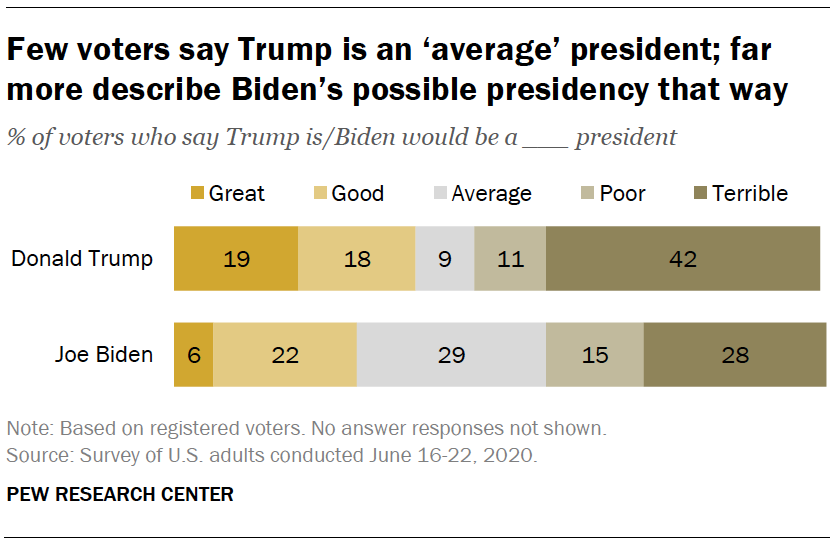Mention a couple of crucial points in this snapshot. The value of the rightmost and topmost bar is 42. In the "Donald Trump" category, the median of all the bars is 18. 